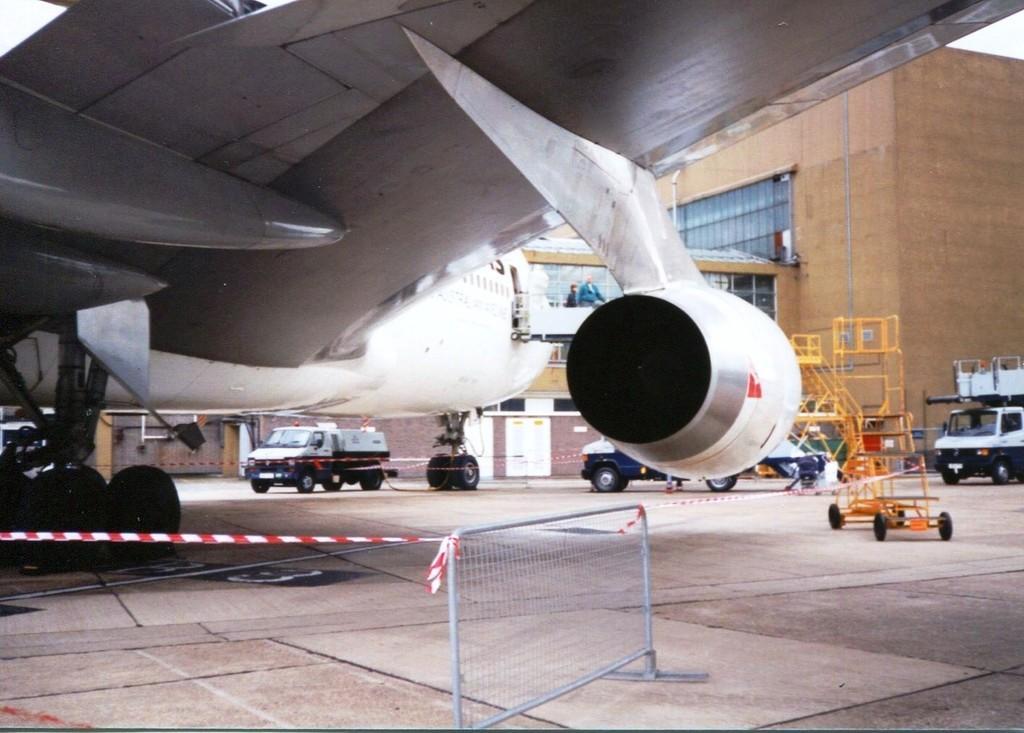Could you give a brief overview of what you see in this image? In this image we can see an airplane and there are few vehicles on the runway and there are two persons standing and we can see the barricade tape. There is a building in the background. 